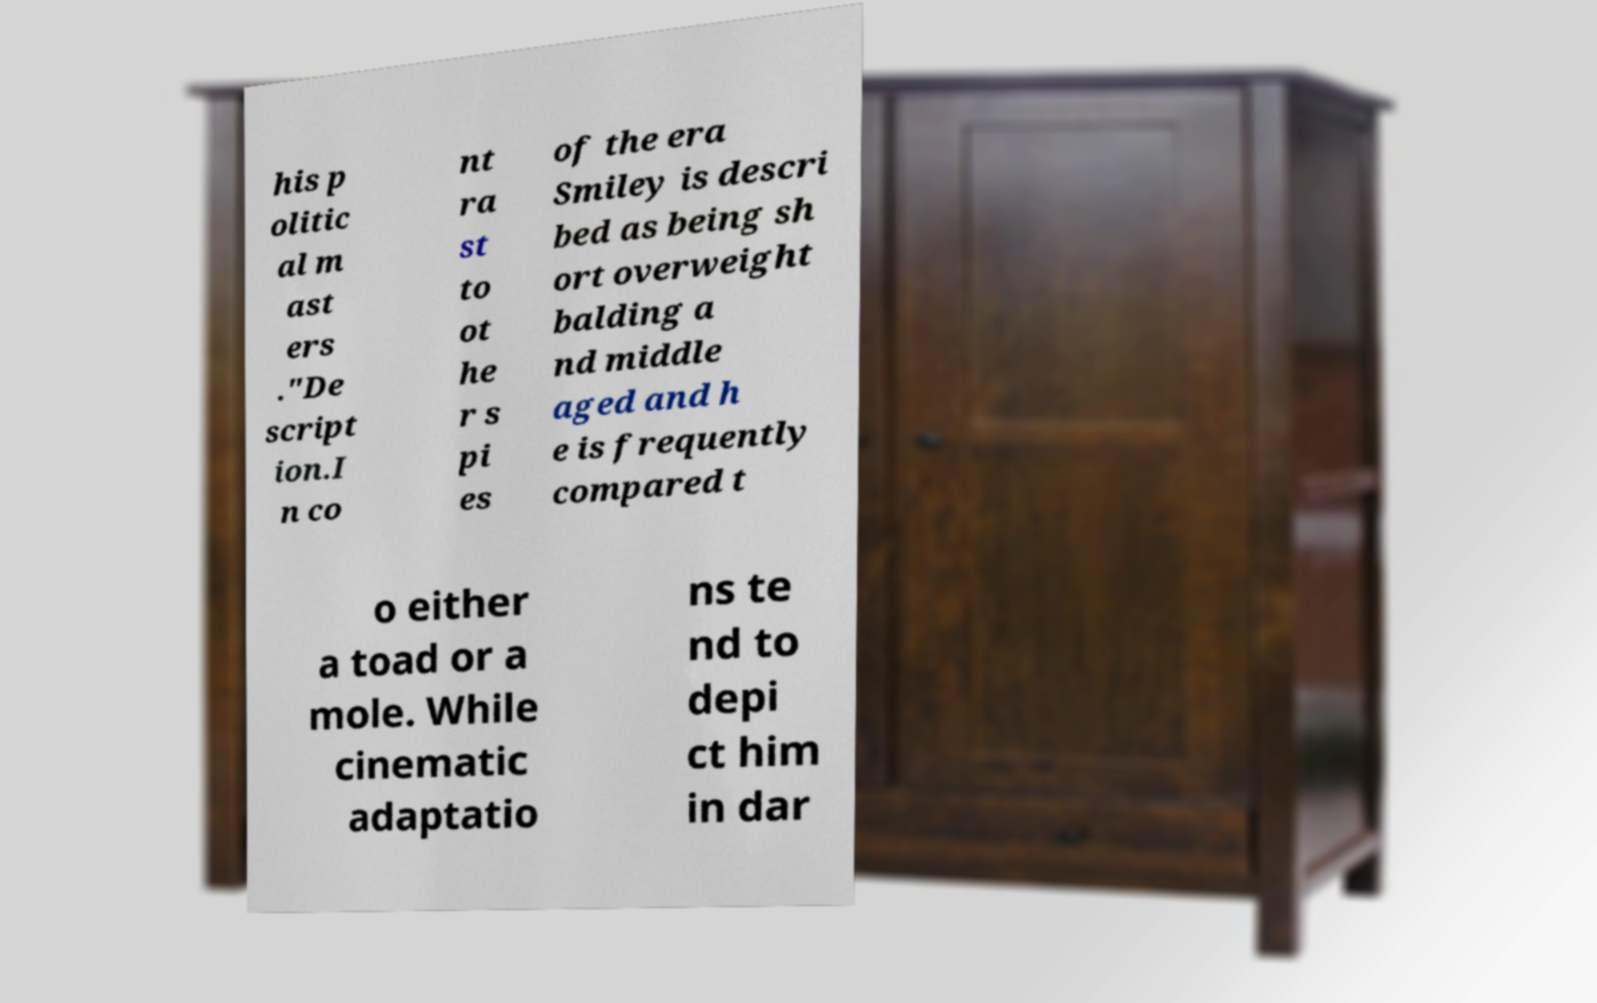Please identify and transcribe the text found in this image. his p olitic al m ast ers ."De script ion.I n co nt ra st to ot he r s pi es of the era Smiley is descri bed as being sh ort overweight balding a nd middle aged and h e is frequently compared t o either a toad or a mole. While cinematic adaptatio ns te nd to depi ct him in dar 